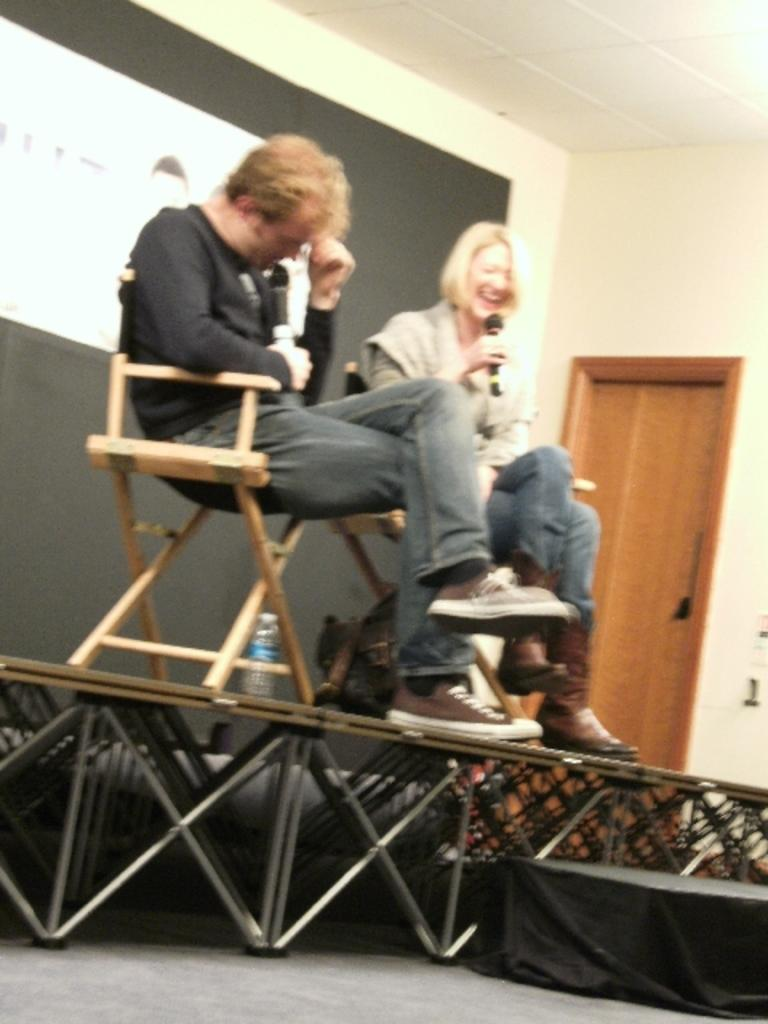How many people are on the stage in the image? There are two persons sitting on chairs on a stage in the image. What is in the background behind the stage? There is a black sheet and a wall in the background. What feature can be seen on the wall? There is a door on the wall. What part of the room is visible above the stage? There is a ceiling visible in the image. What type of shoe is the writer wearing in the image? There is no writer present in the image, and therefore no shoes to describe. 